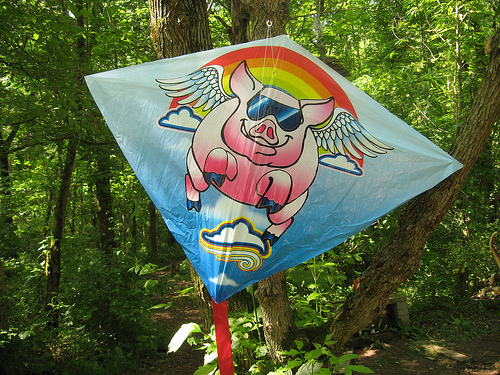<image>
Can you confirm if the kite is in the tree? No. The kite is not contained within the tree. These objects have a different spatial relationship. 